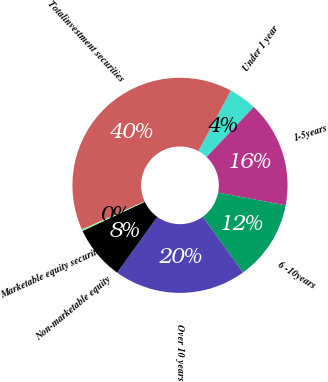<chart> <loc_0><loc_0><loc_500><loc_500><pie_chart><fcel>Under 1 year<fcel>1-5years<fcel>6 -10years<fcel>Over 10 years<fcel>Non-marketable equity<fcel>Marketable equity securities<fcel>Totalinvestment securities<nl><fcel>4.18%<fcel>15.97%<fcel>12.04%<fcel>19.9%<fcel>8.11%<fcel>0.25%<fcel>39.56%<nl></chart> 